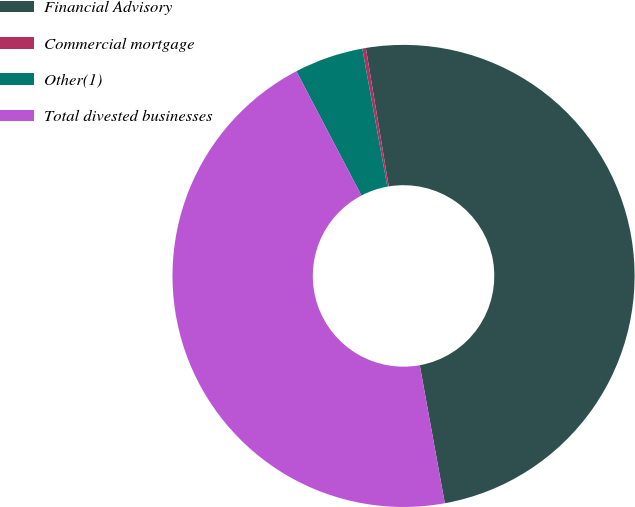Convert chart. <chart><loc_0><loc_0><loc_500><loc_500><pie_chart><fcel>Financial Advisory<fcel>Commercial mortgage<fcel>Other(1)<fcel>Total divested businesses<nl><fcel>49.75%<fcel>0.25%<fcel>4.82%<fcel>45.18%<nl></chart> 